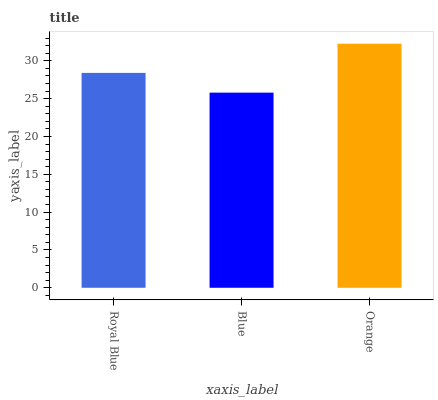Is Blue the minimum?
Answer yes or no. Yes. Is Orange the maximum?
Answer yes or no. Yes. Is Orange the minimum?
Answer yes or no. No. Is Blue the maximum?
Answer yes or no. No. Is Orange greater than Blue?
Answer yes or no. Yes. Is Blue less than Orange?
Answer yes or no. Yes. Is Blue greater than Orange?
Answer yes or no. No. Is Orange less than Blue?
Answer yes or no. No. Is Royal Blue the high median?
Answer yes or no. Yes. Is Royal Blue the low median?
Answer yes or no. Yes. Is Blue the high median?
Answer yes or no. No. Is Blue the low median?
Answer yes or no. No. 